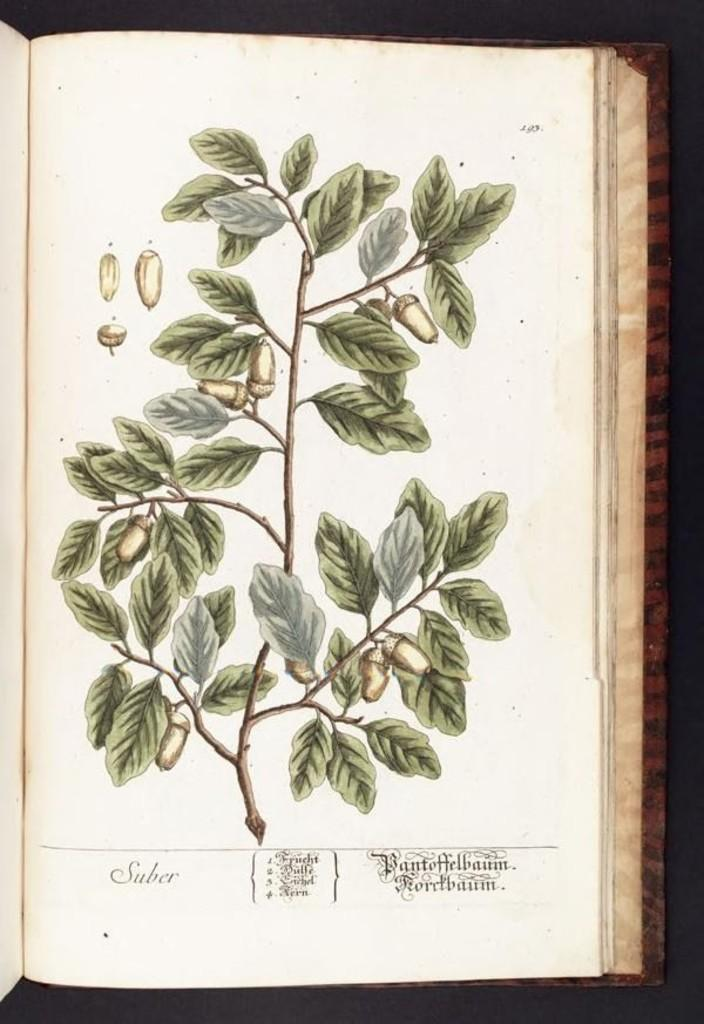What is depicted in the image? There is a drawing of a plant in the image. Where is the drawing located? The drawing is on a page of a book. What type of teaching method is being demonstrated in the image? There is no teaching method or any indication of teaching in the image; it only features a drawing of a plant on a page of a book. 